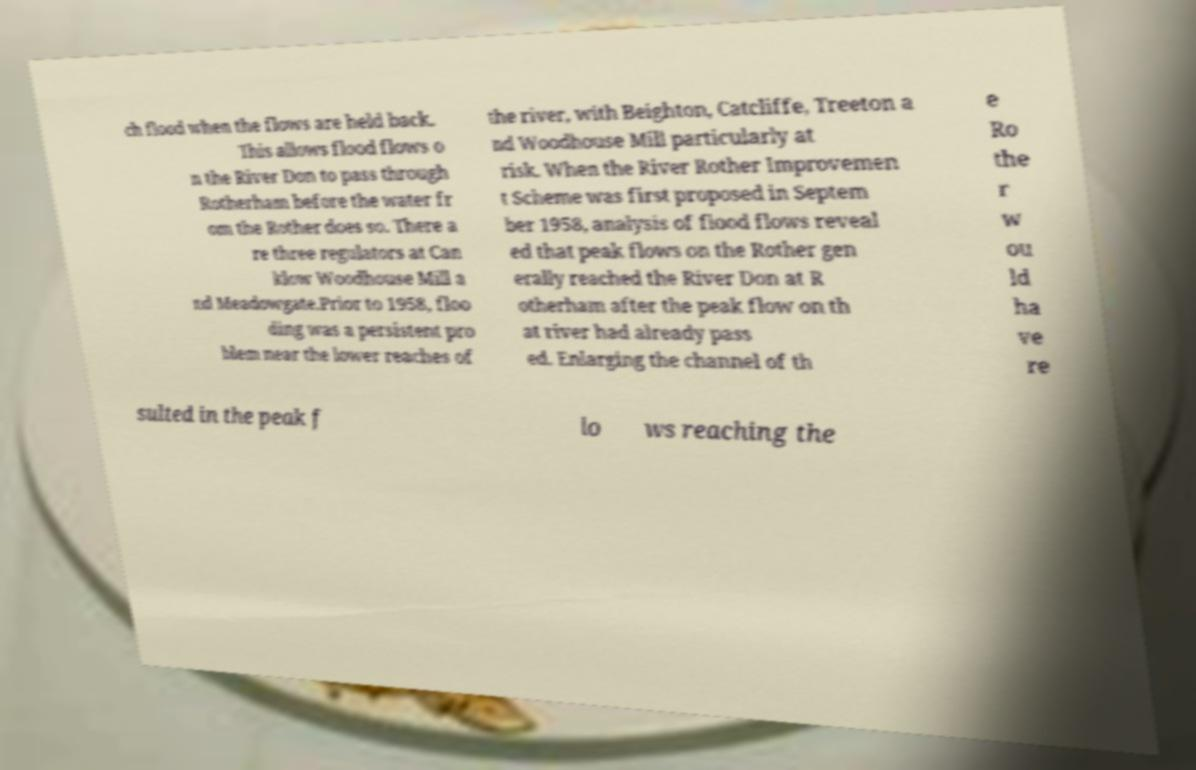Please identify and transcribe the text found in this image. ch flood when the flows are held back. This allows flood flows o n the River Don to pass through Rotherham before the water fr om the Rother does so. There a re three regulators at Can klow Woodhouse Mill a nd Meadowgate.Prior to 1958, floo ding was a persistent pro blem near the lower reaches of the river, with Beighton, Catcliffe, Treeton a nd Woodhouse Mill particularly at risk. When the River Rother Improvemen t Scheme was first proposed in Septem ber 1958, analysis of flood flows reveal ed that peak flows on the Rother gen erally reached the River Don at R otherham after the peak flow on th at river had already pass ed. Enlarging the channel of th e Ro the r w ou ld ha ve re sulted in the peak f lo ws reaching the 